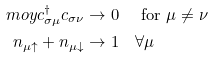<formula> <loc_0><loc_0><loc_500><loc_500>\ m o y { c _ { \sigma \mu } ^ { \dagger } c _ { \sigma \nu } } & \rightarrow 0 \quad \text { for } \mu \neq \nu \\ n _ { \mu \uparrow } + n _ { \mu \downarrow } & \rightarrow 1 \quad \forall \mu</formula> 